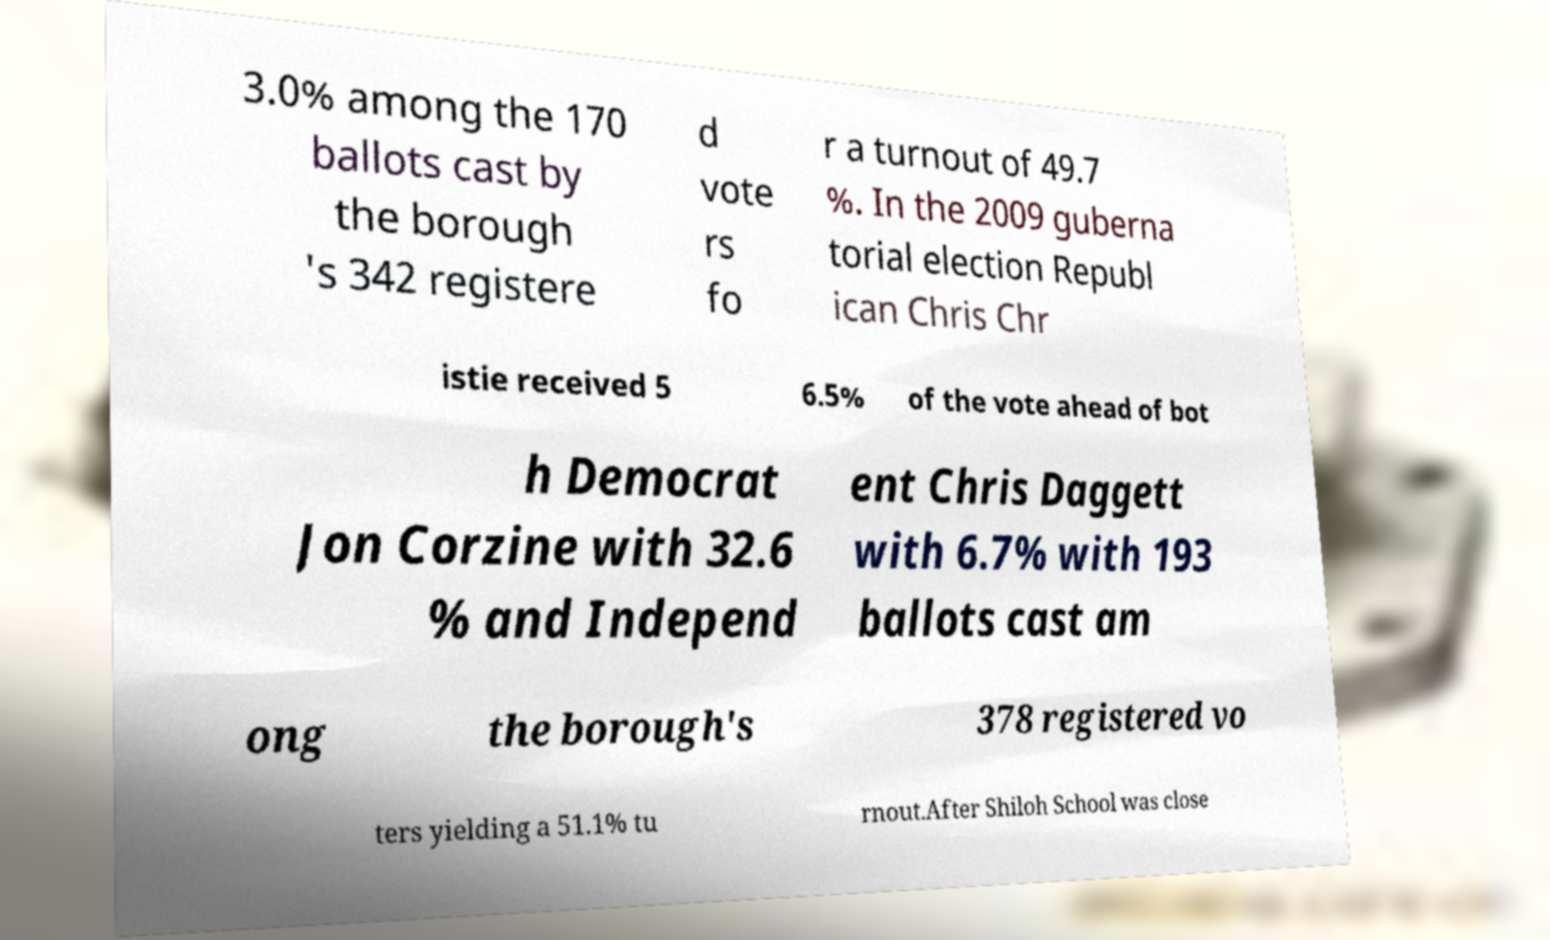What messages or text are displayed in this image? I need them in a readable, typed format. 3.0% among the 170 ballots cast by the borough 's 342 registere d vote rs fo r a turnout of 49.7 %. In the 2009 guberna torial election Republ ican Chris Chr istie received 5 6.5% of the vote ahead of bot h Democrat Jon Corzine with 32.6 % and Independ ent Chris Daggett with 6.7% with 193 ballots cast am ong the borough's 378 registered vo ters yielding a 51.1% tu rnout.After Shiloh School was close 